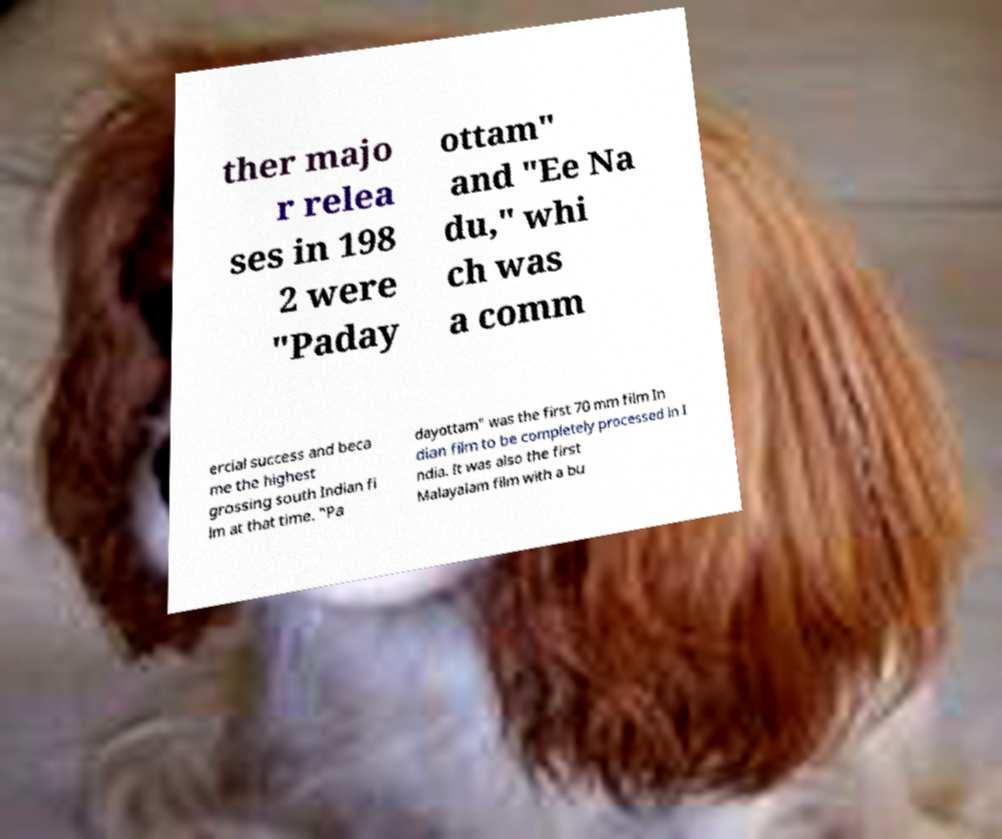Could you extract and type out the text from this image? ther majo r relea ses in 198 2 were "Paday ottam" and "Ee Na du," whi ch was a comm ercial success and beca me the highest grossing south Indian fi lm at that time. "Pa dayottam" was the first 70 mm film In dian film to be completely processed in I ndia. It was also the first Malayalam film with a bu 